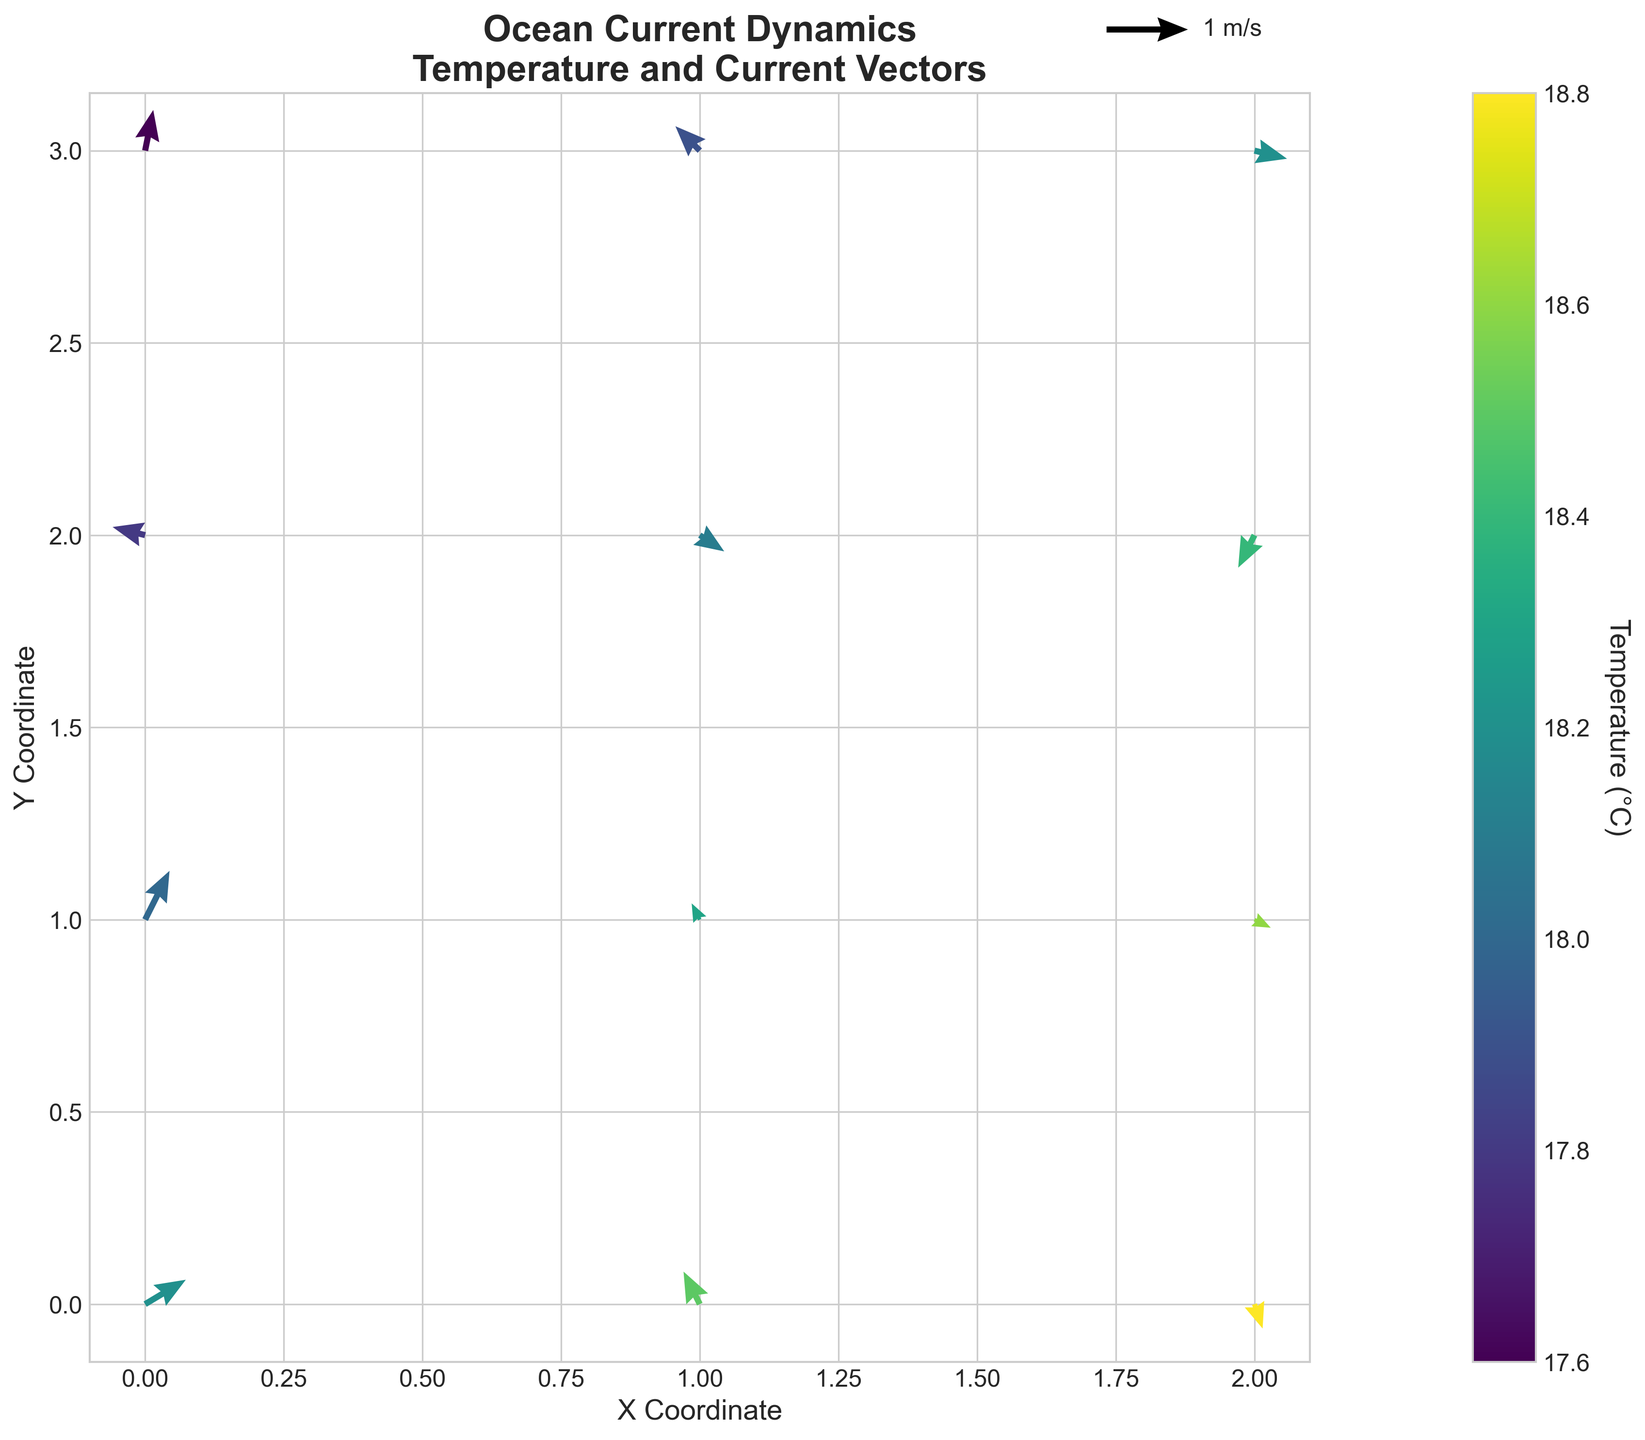What's the main title of the figure? The main title of the figure is displayed at the top in bold, which states, "Ocean Current Dynamics\nTemperature and Current Vectors".
Answer: Ocean Current Dynamics\nTemperature and Current Vectors What variable does the color bar represent? The color bar located at the side of the quiver plot represents the variable labeled as "Temperature (°C)". This indicates that the colors of the arrows correlate to different temperatures in degrees Celsius.
Answer: Temperature (°C) What does the length of the arrows represent in the plot? The length of the arrows represents the magnitude of the current vectors. Specifically, longer arrows indicate stronger current strengths, and the reference vector labeled as '1 m/s' shows the scale.
Answer: Current magnitude Which location has the highest temperature as indicated in the plot? The color of the arrows indicates the temperature, with higher temperatures shown in lighter colors according to the color bar. The arrow at coordinates (2,0) has the lightest color, which correlates with the highest temperature.
Answer: (2,0) Compare the current direction at point (1,0) and point (1,3). Which direction is more towards the north? At (1,0), the vector points primarily northward (v=0.4), whereas at (1,3), the vector points slightly northward (v=0.3). Therefore, the vector at (1,0) is more towards the north.
Answer: (1,0) What is the average temperature of the points along the y=0 axis? Along the y=0 axis, the temperatures are 18.2, 18.5, and 18.8. The average is calculated as (18.2 + 18.5 + 18.8) / 3 = 18.5 °C.
Answer: 18.5 °C How does the current vector at (0,3) compare in magnitude and direction to the current vector at (2,3)? The vector at (0,3) has components u=0.1 and v=0.5, while the vector at (2,3) has components u=0.4 and v=-0.1. The magnitude for (0,3) is sqrt(0.1^2 + 0.5^2) ≈ 0.51 and for (2,3) is sqrt(0.4^2 + -0.1^2) ≈ 0.41. Therefore, (0,3) has a larger magnitude and points more northward compared to (2,3), which points mostly eastward.
Answer: (0,3) larger magnitude, more northward Summarize the general pattern of ocean currents and temperature variations observed in the plot. By observing the vector directions and colors, one can see that currents are varying throughout, with warmer temperatures generally found in the northern regions and cooler temperatures in the southern regions. Arrows pointing different directions and varying temperatures depict a complex dynamic of ocean currents.
Answer: Northern warmer, southern cooler, varied currents At which points do the currents have a negative u-component? Checking the u-components for negative values, we see that points with a negative u-component (leftward direction) are (1,0), (0,2), (2,2), and (1,3).
Answer: (1,0), (0,2), (2,2), (1,3) Is there a correlation between temperature and salinity represented in the plot? While the plot directly shows temperature and current vectors, salinity data are not visibly represented, making it impossible to state a correlation based solely on this visual. However, exploratory analysis requires referencing the dataset directly.
Answer: Not visible in plot 